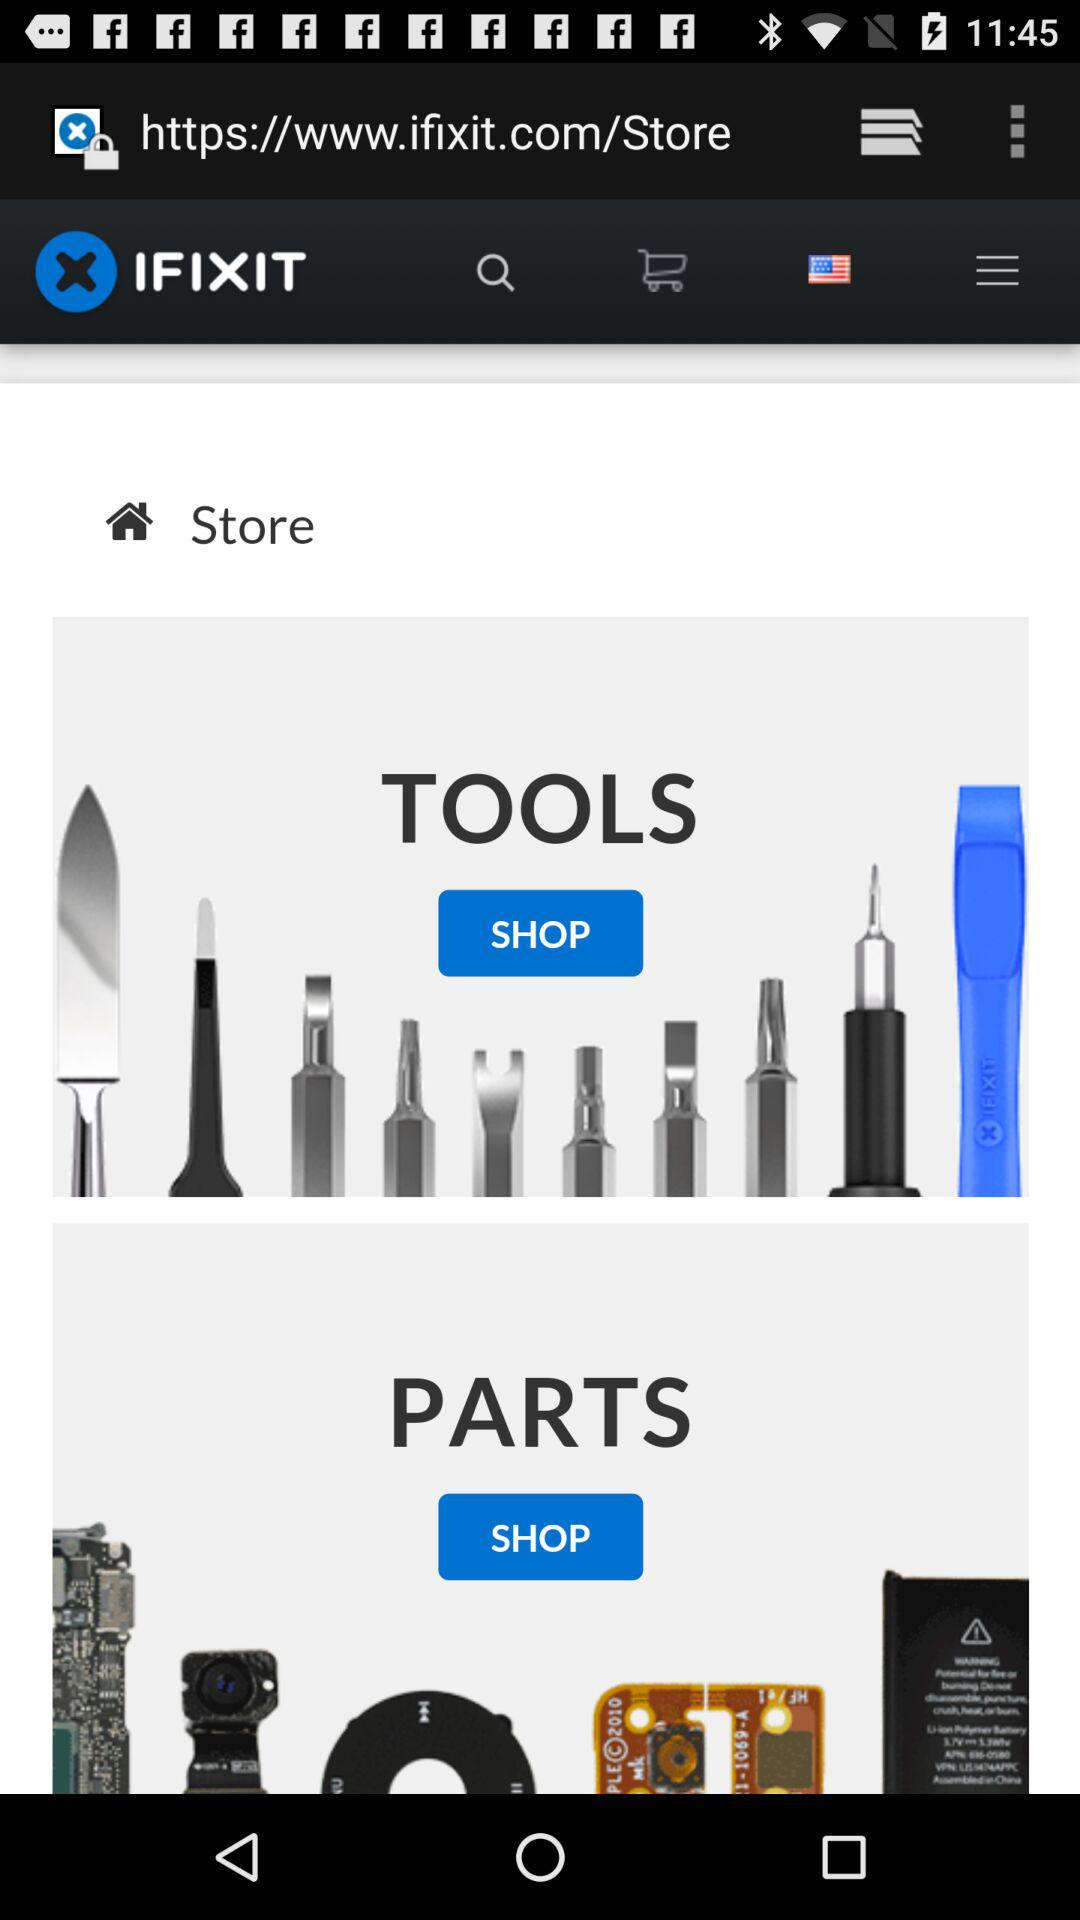What is the app name? The app name is "IFIXIT". 